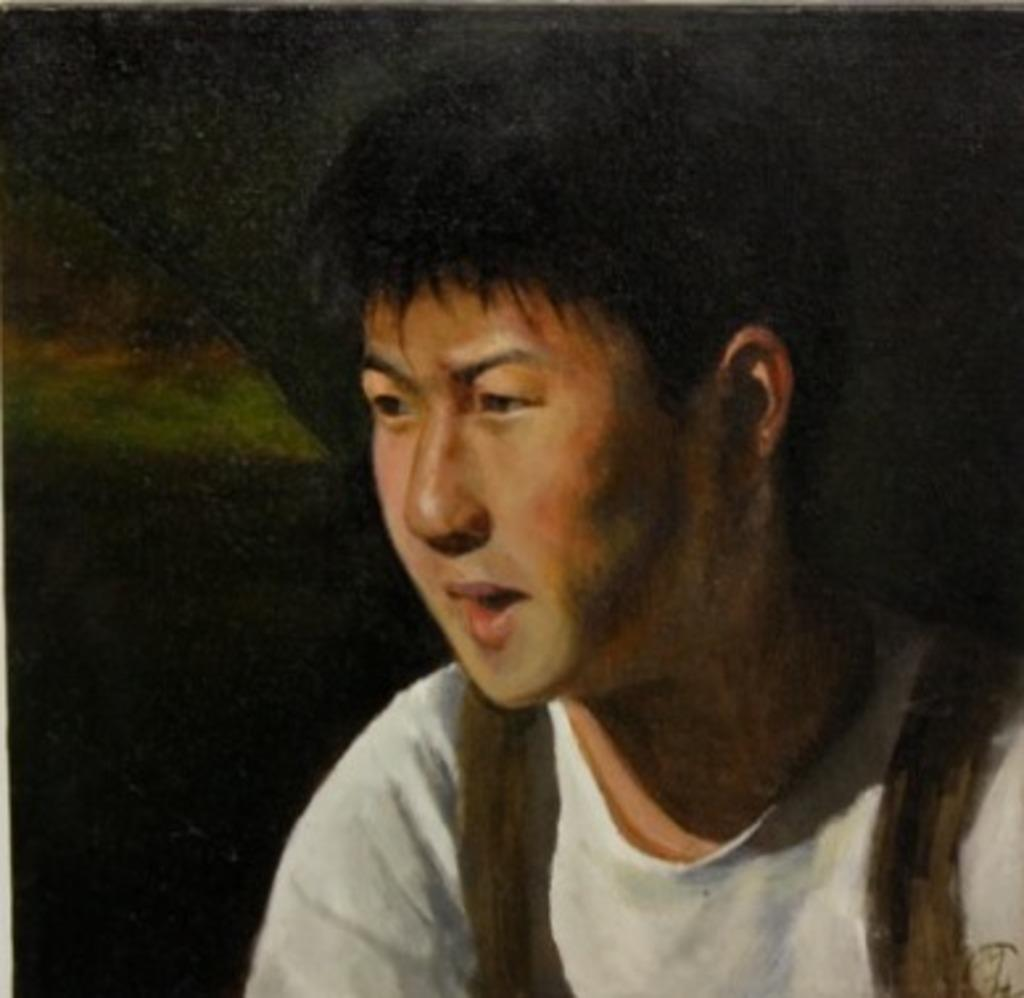What is depicted in the painting in the image? There is a painting of a man in the image. What can be observed about the overall color scheme of the image? The background of the image is dark. How many zebras can be seen in the painting? There are no zebras depicted in the painting; it features a man. What is the texture of the man's tongue in the painting? There is no information about the man's tongue in the painting, as the focus is on the overall image of the man. 